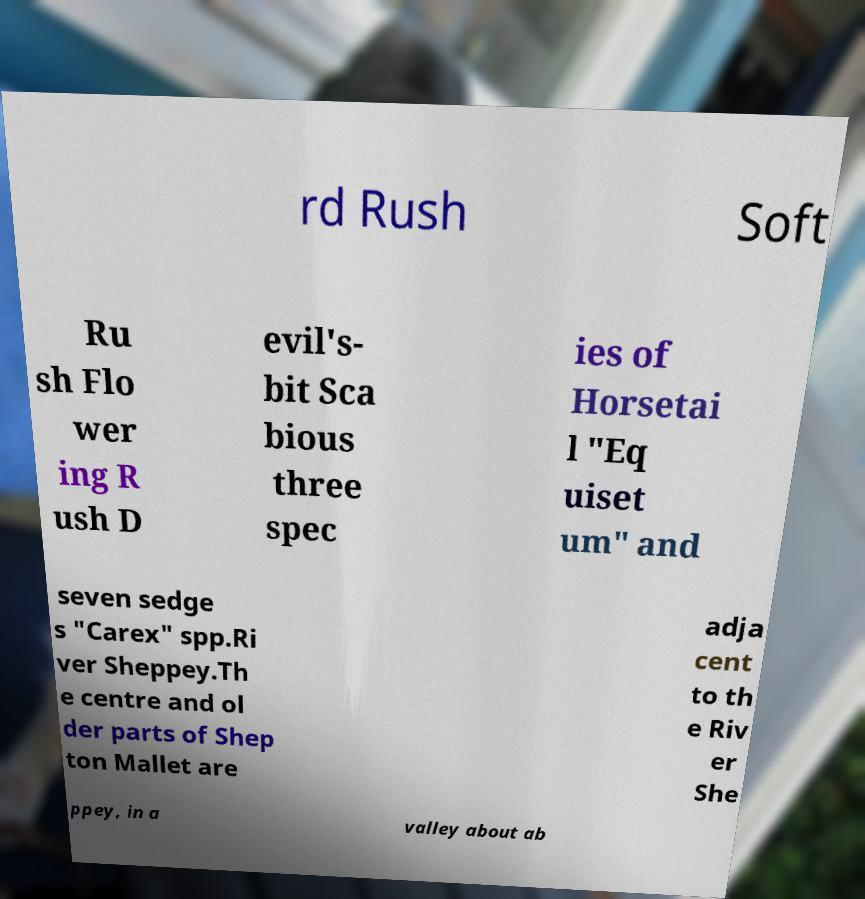I need the written content from this picture converted into text. Can you do that? rd Rush Soft Ru sh Flo wer ing R ush D evil's- bit Sca bious three spec ies of Horsetai l "Eq uiset um" and seven sedge s "Carex" spp.Ri ver Sheppey.Th e centre and ol der parts of Shep ton Mallet are adja cent to th e Riv er She ppey, in a valley about ab 